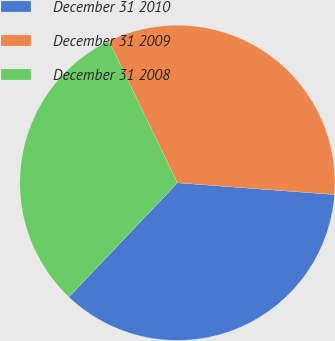Convert chart. <chart><loc_0><loc_0><loc_500><loc_500><pie_chart><fcel>December 31 2010<fcel>December 31 2009<fcel>December 31 2008<nl><fcel>35.91%<fcel>33.35%<fcel>30.74%<nl></chart> 